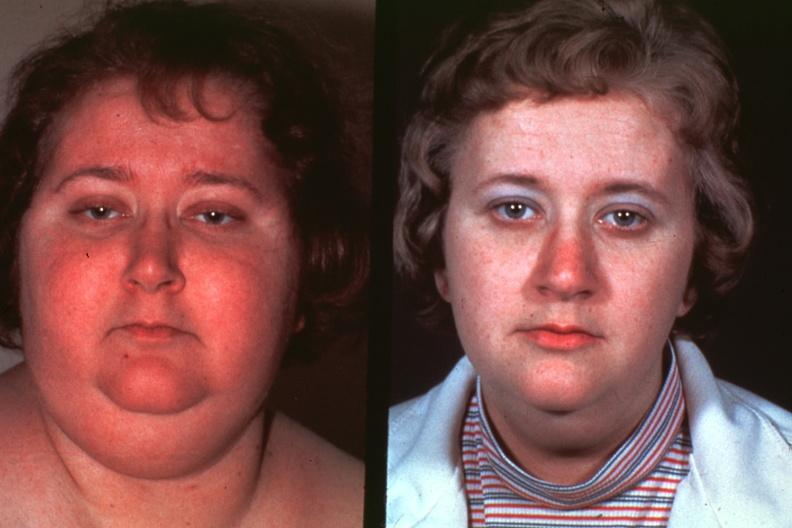does this image show photos of lady before disease and after excellent?
Answer the question using a single word or phrase. Yes 